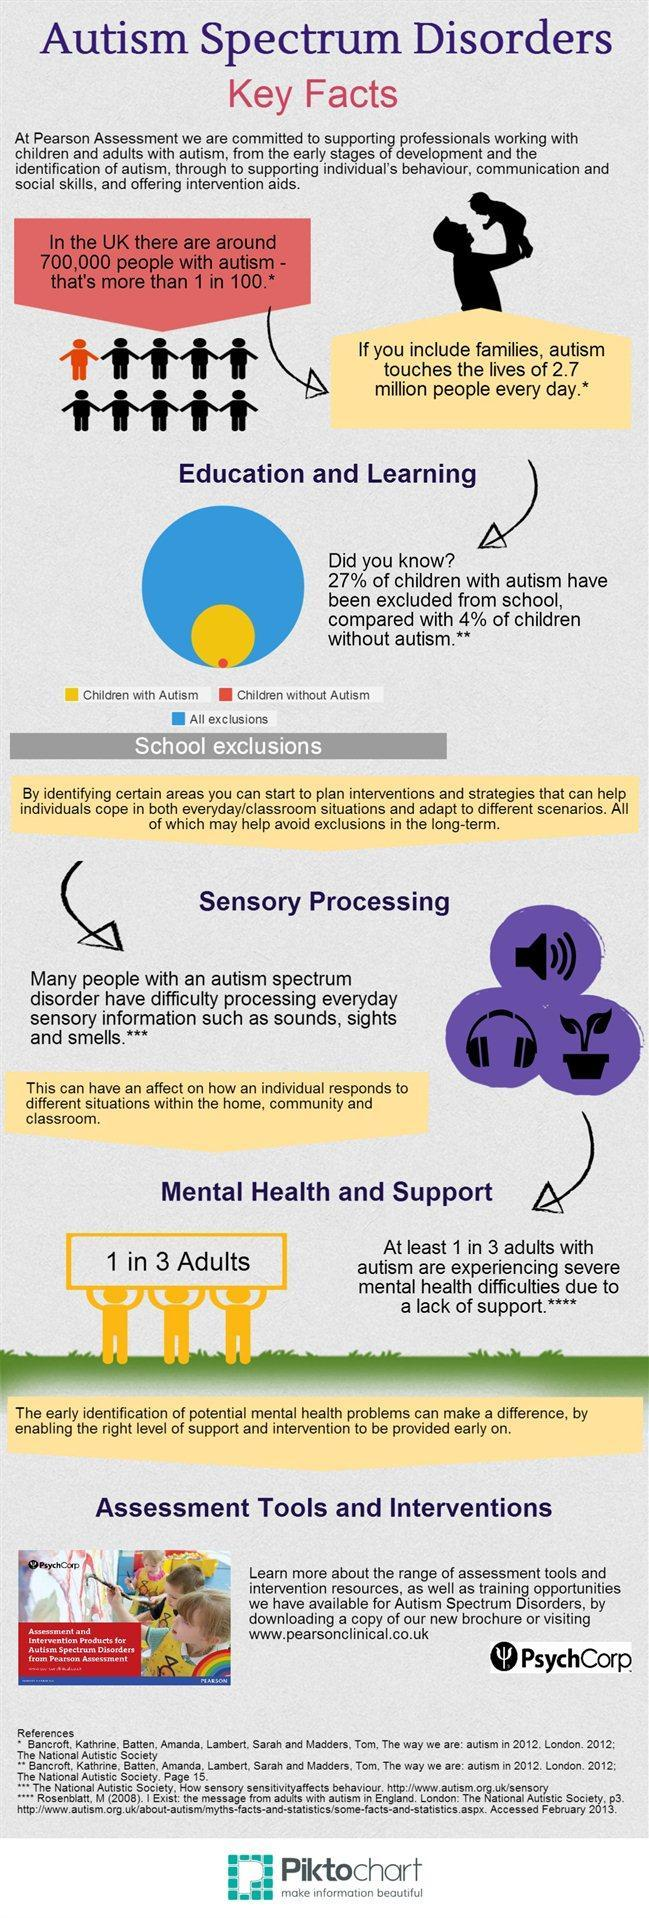Out of every three autistic adults, how many suffer from acute mental health problems?
Answer the question with a short phrase. 1 What percentage of school exclusions  are autistic? 27% What are the sensory inputs that cannot be processed by autistic people? Sounds, sights and smells What is the percentage of people with autism in UK? 1% In the pie chart, what colour is used to represent children with autism - blue, orange or yellow? Yellow 